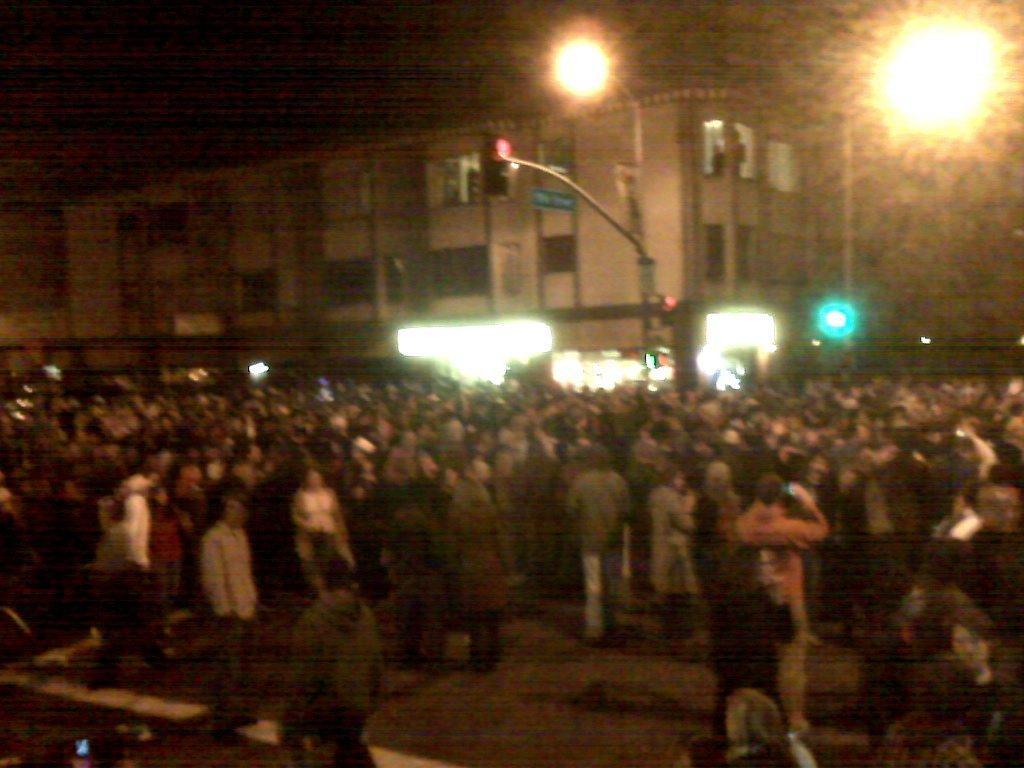Could you give a brief overview of what you see in this image? In this image I can see the group of people with different color dresses. In the background I can see the boards, poles, building and the lights. And there is a black background. 